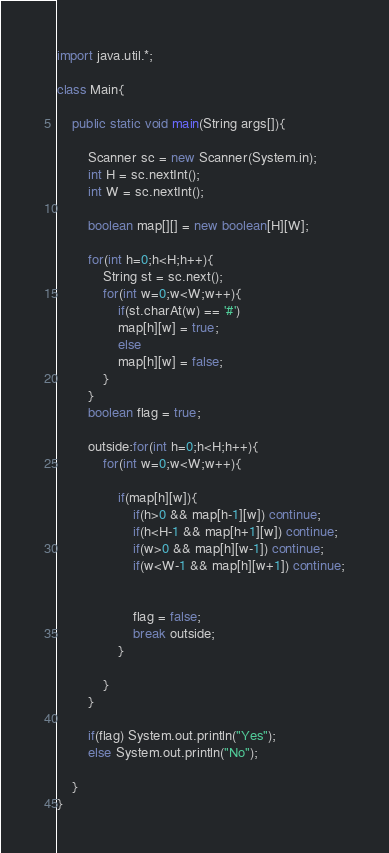Convert code to text. <code><loc_0><loc_0><loc_500><loc_500><_Java_>import java.util.*;

class Main{
	
	public static void main(String args[]){

		Scanner sc = new Scanner(System.in);
		int H = sc.nextInt();
		int W = sc.nextInt();

		boolean map[][] = new boolean[H][W];

		for(int h=0;h<H;h++){
			String st = sc.next();
			for(int w=0;w<W;w++){
				if(st.charAt(w) == '#')
				map[h][w] = true;
				else
				map[h][w] = false;
 			}
		}
		boolean flag = true;

		outside:for(int h=0;h<H;h++){
			for(int w=0;w<W;w++){

				if(map[h][w]){
					if(h>0 && map[h-1][w]) continue;
					if(h<H-1 && map[h+1][w]) continue;
					if(w>0 && map[h][w-1]) continue;
					if(w<W-1 && map[h][w+1]) continue;


					flag = false;
					break outside;
				}
				
 			}
		}

		if(flag) System.out.println("Yes");
		else System.out.println("No");

	}
}</code> 